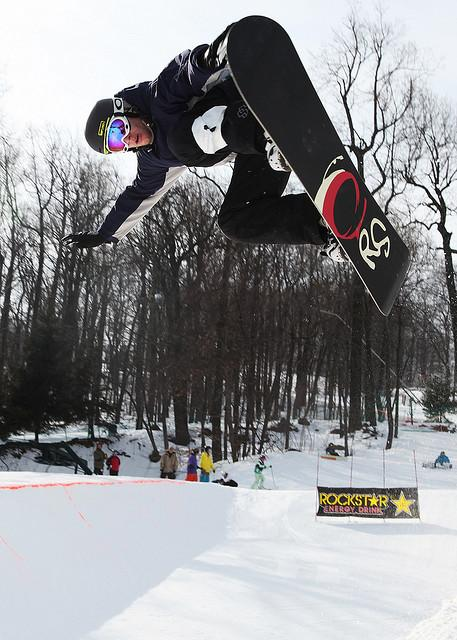How many flavors available in Rock star energy drink? multiple 